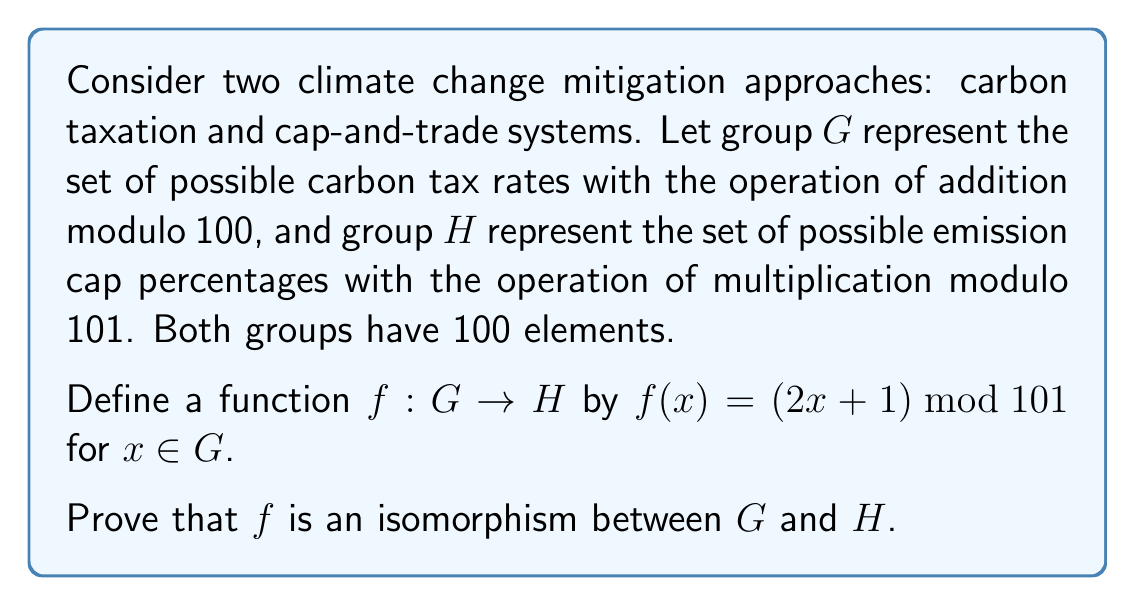Can you answer this question? To prove that $f$ is an isomorphism between $G$ and $H$, we need to show that $f$ is both a homomorphism and a bijection.

1. Prove $f$ is a homomorphism:
   For $a, b \in G$, we need to show that $f(a + b) = f(a) \cdot f(b)$ (where $+$ is addition modulo 100 in $G$ and $\cdot$ is multiplication modulo 101 in $H$).

   $$\begin{align*}
   f(a + b) &= (2((a + b) \bmod 100) + 1) \bmod 101 \\
   &= (2a + 2b + 1) \bmod 101 \\
   f(a) \cdot f(b) &= ((2a + 1) \bmod 101) \cdot ((2b + 1) \bmod 101) \bmod 101 \\
   &= (4ab + 2a + 2b + 1) \bmod 101 \\
   &= (2a + 2b + 1) \bmod 101 \quad \text{(since } 4ab \equiv 0 \pmod{101}\text{)}
   \end{align*}$$

   Thus, $f(a + b) = f(a) \cdot f(b)$, so $f$ is a homomorphism.

2. Prove $f$ is injective:
   For $a, b \in G$, if $f(a) = f(b)$, then:
   $$(2a + 1) \bmod 101 = (2b + 1) \bmod 101$$
   $$2a \equiv 2b \pmod{101}$$
   $$a \equiv b \pmod{101}$$
   Since $a, b \in \{0, 1, \ldots, 99\}$, we have $a = b$. Thus, $f$ is injective.

3. Prove $f$ is surjective:
   For any $y \in H$, we need to find an $x \in G$ such that $f(x) = y$.
   Let $x = ((y - 1) \cdot 50) \bmod 100$. Then:
   $$\begin{align*}
   f(x) &= (2x + 1) \bmod 101 \\
   &= (2((y - 1) \cdot 50 \bmod 100) + 1) \bmod 101 \\
   &= (100(y - 1) + 1) \bmod 101 \\
   &= y
   \end{align*}$$
   Thus, $f$ is surjective.

Since $f$ is both injective and surjective, it is bijective.

Therefore, $f$ is an isomorphism between $G$ and $H$.
Answer: The function $f: G \rightarrow H$ defined by $f(x) = (2x + 1) \bmod 101$ is an isomorphism between $G$ and $H$, as it is both a homomorphism and a bijection. 